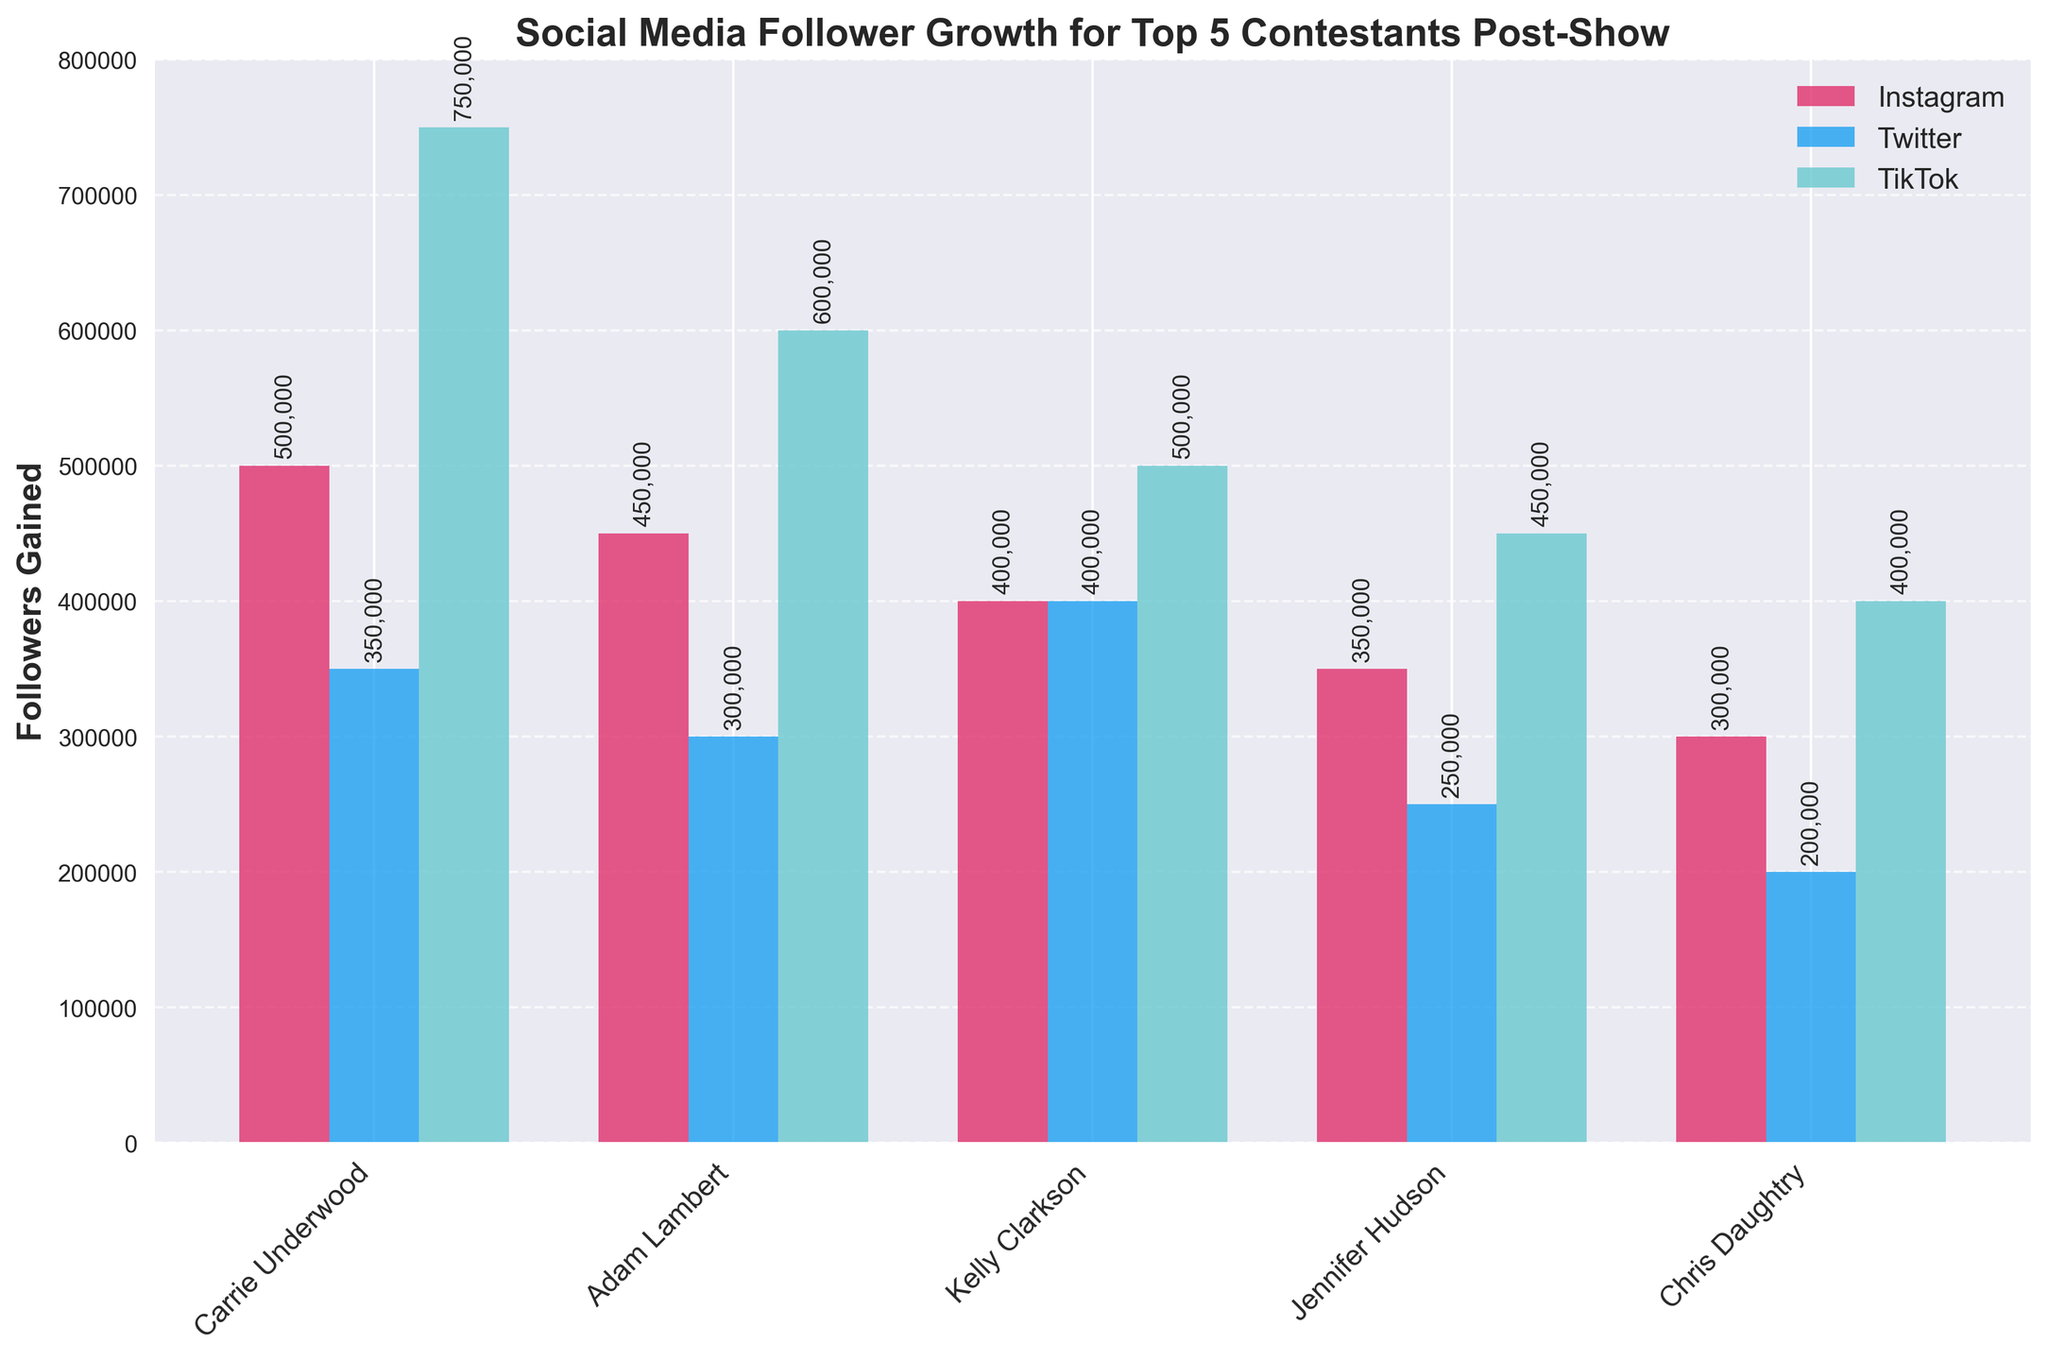What is the difference in the number of Instagram followers gained between Carrie Underwood and Chris Daughtry? First, look at the heights of the bars in the 'Instagram' series for Carrie Underwood and Chris Daughtry. Carrie gained 500,000 followers, while Chris gained 300,000 followers. Subtract Chris's followers from Carrie's: 500,000 - 300,000.
Answer: 200,000 Who gained the most TikTok followers and how many did they gain? Examine the heights of the bars in the 'TikTok' series for all contestants. Carrie Underwood's bar is the tallest, showing she gained the most TikTok followers.
Answer: Carrie Underwood, 750,000 Which contestant had the least gain in Twitter followers? Check the heights of the bars in the 'Twitter' series. The shortest bar belongs to Chris Daughtry.
Answer: Chris Daughtry What is the combined increase in Instagram and TikTok followers for Adam Lambert? Identify Adam Lambert's Instagram and TikTok followers gained from the heights of the respective bars, which are 450,000 and 600,000 respectively. Add these two values: 450,000 + 600,000.
Answer: 1,050,000 How many more Twitter followers did Kelly Clarkson gain compared to Jennifer Hudson? Look at the Twitter followers gained for both Kelly Clarkson and Jennifer Hudson, which are 400,000 and 250,000 respectively. Subtract Jennifer's followers from Kelly's: 400,000 - 250,000.
Answer: 150,000 On which platform did Jennifer Hudson see the smallest follower increase? Compare the heights of the bars for Jennifer Hudson across Instagram, Twitter, and TikTok. The Twitter bar is the shortest, indicating the smallest increase on that platform.
Answer: Twitter How many total followers did Chris Daughtry gain across all three platforms? Check the followers gained for Chris Daughtry on Instagram, Twitter, and TikTok, which are 300,000, 200,000, and 400,000 respectively. Sum these values: 300,000 + 200,000 + 400,000.
Answer: 900,000 Who gained more Instagram followers, Adam Lambert or Kelly Clarkson, and by how many? Identify the Instagram followers gained for both Adam Lambert and Kelly Clarkson, which are 450,000 and 400,000 respectively. Subtract Kelly's followers from Adam's: 450,000 - 400,000.
Answer: Adam Lambert, 50,000 Which social media platform showed the greatest overall follower increase across all contestants? Sum the follower increases across all contestants for each platform. Instagram: 500,000 + 450,000 + 400,000 + 350,000 + 300,000 = 2,000,000. Twitter: 350,000 + 300,000 + 400,000 + 250,000 + 200,000 = 1,500,000. TikTok: 750,000 + 600,000 + 500,000 + 450,000 + 400,000 = 2,700,000. The highest total is for TikTok.
Answer: TikTok 